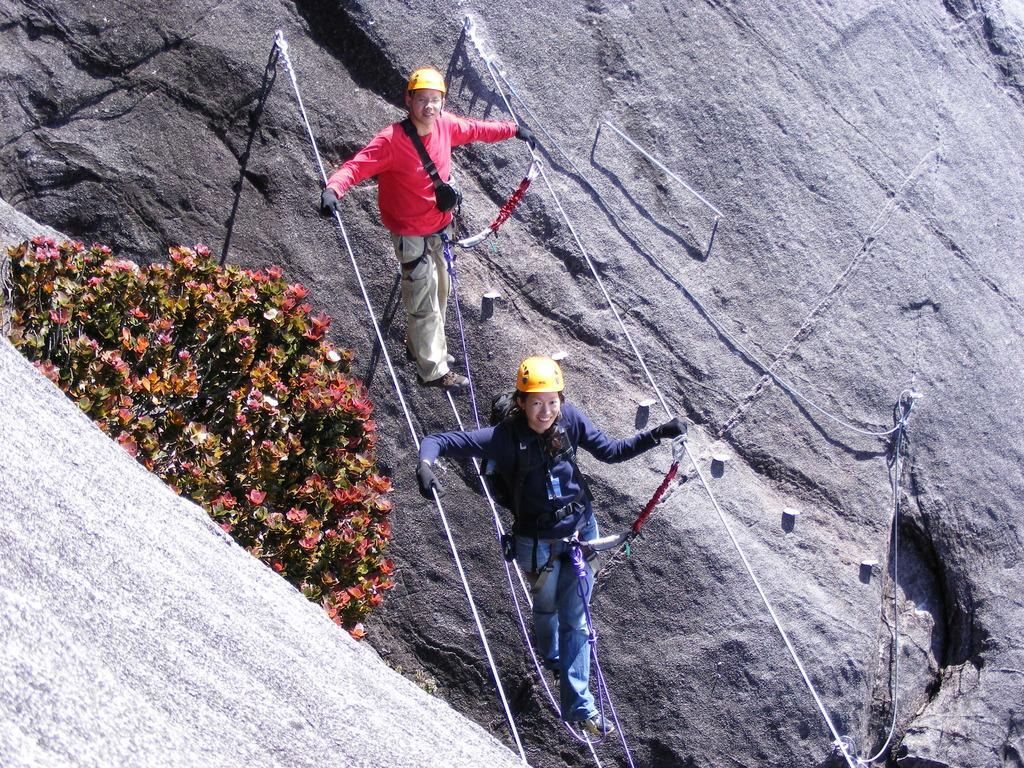What are the two persons in the image doing? The two persons are walking on a rope in the image. What can be seen in the background of the image? There are plants and a mountain visible in the image. What type of underwear is visible on the mountain? There is no underwear visible in the image, as the focus is on the two persons walking on a rope and the plants and the mountain. 